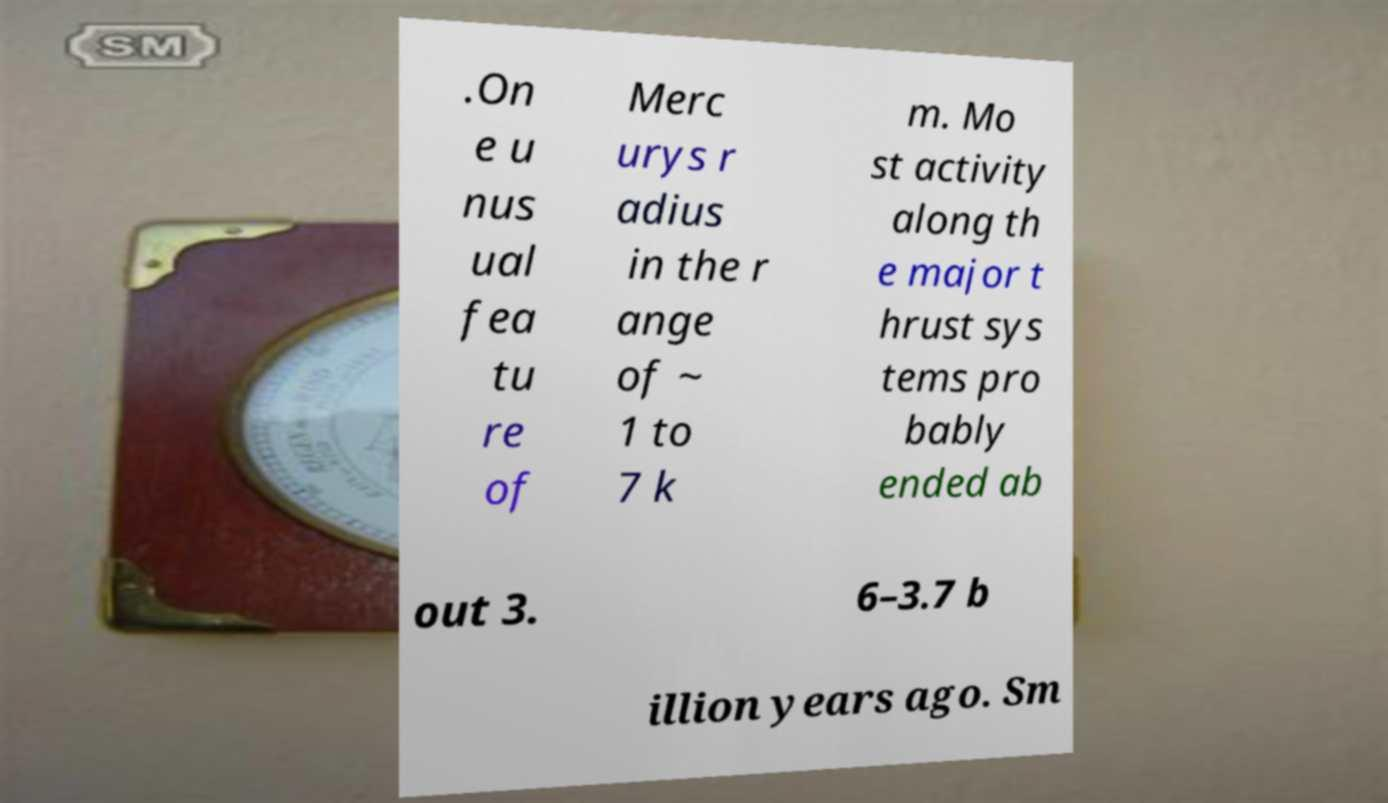I need the written content from this picture converted into text. Can you do that? .On e u nus ual fea tu re of Merc urys r adius in the r ange of ~ 1 to 7 k m. Mo st activity along th e major t hrust sys tems pro bably ended ab out 3. 6–3.7 b illion years ago. Sm 